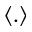<formula> <loc_0><loc_0><loc_500><loc_500>\langle . \rangle</formula> 